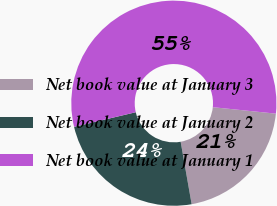<chart> <loc_0><loc_0><loc_500><loc_500><pie_chart><fcel>Net book value at January 3<fcel>Net book value at January 2<fcel>Net book value at January 1<nl><fcel>20.6%<fcel>24.07%<fcel>55.32%<nl></chart> 